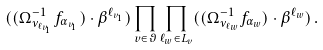Convert formula to latex. <formula><loc_0><loc_0><loc_500><loc_500>( ( \Omega ^ { - 1 } _ { \nu _ { \ell _ { v _ { 1 } } } } { f } _ { \alpha _ { v _ { 1 } } } ) \cdot \beta ^ { \ell _ { v _ { 1 } } } ) \prod _ { v \in \vartheta } \prod _ { \ell _ { w } \in L _ { v } } ( ( \Omega ^ { - 1 } _ { \nu _ { \ell _ { w } } } { f } _ { \alpha _ { w } } ) \cdot \beta ^ { \ell _ { w } } ) \, .</formula> 